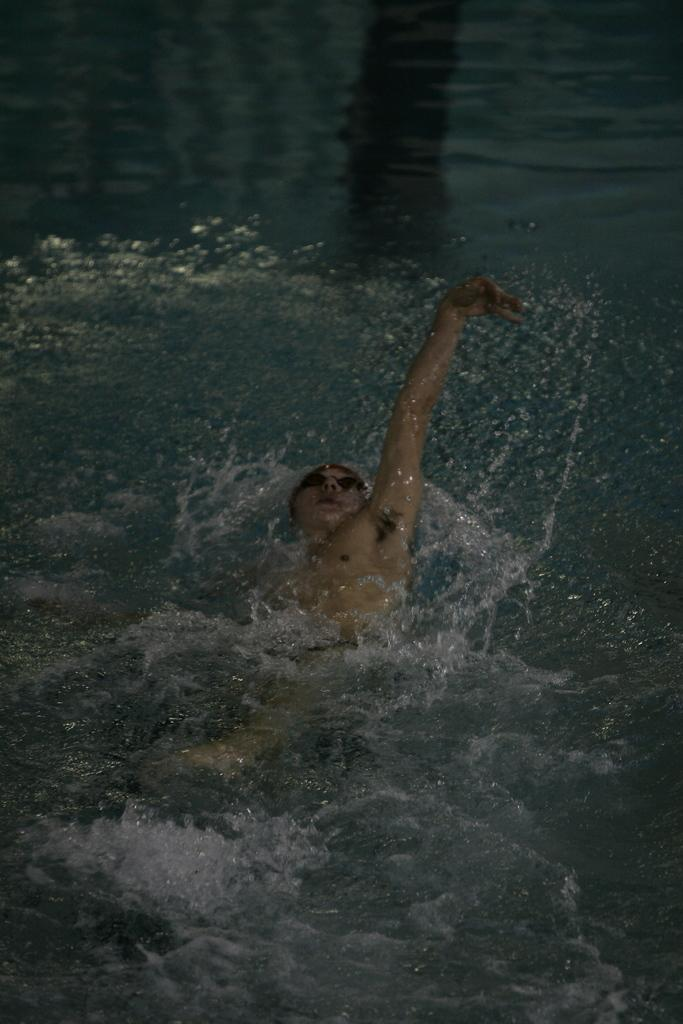Who is present in the image? There is a person in the image. What is the person doing in the image? The person is swimming in the water. What type of waste can be seen on the road near the person in the image? There is no road or waste present in the image; it features a person swimming in the water. Can you tell me the age of the person's grandfather in the image? There is no mention of a grandfather or age in the image; it only shows a person swimming in the water. 